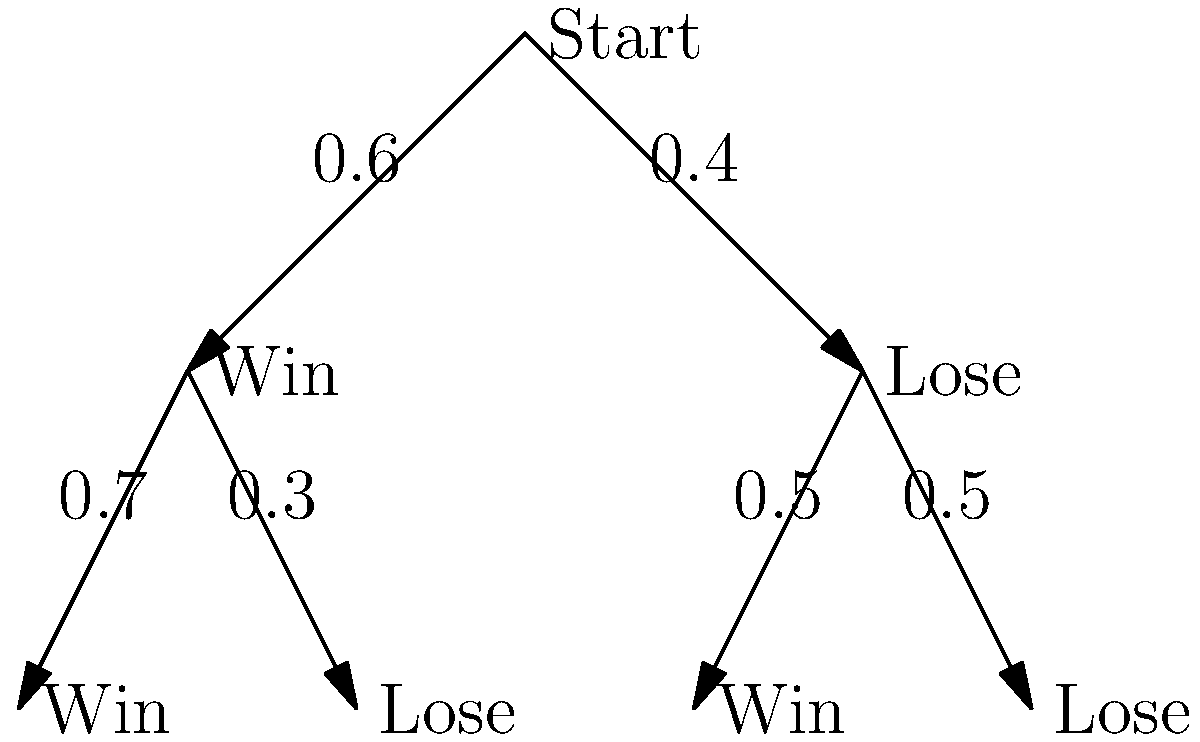In a two-game series, a team has a 60% chance of winning the first game. If they win the first game, their probability of winning the second game increases to 70%. If they lose the first game, their probability of winning the second game is 50%. What is the probability that the team will win both games in the series? To solve this problem, we'll use the decision tree diagram and follow these steps:

1. Identify the probability of winning the first game: $P(\text{Win 1st}) = 0.6$

2. Given that the team wins the first game, identify the probability of winning the second game: $P(\text{Win 2nd | Win 1st}) = 0.7$

3. Calculate the probability of winning both games by multiplying these probabilities:

   $P(\text{Win both}) = P(\text{Win 1st}) \times P(\text{Win 2nd | Win 1st})$
   
   $P(\text{Win both}) = 0.6 \times 0.7 = 0.42$

4. Convert the decimal to a percentage:

   $0.42 \times 100\% = 42\%$

This approach utilizes the multiplicative rule of probability for independent events, which aligns with the progressive coach's reliance on statistics and modern techniques.
Answer: 42% 